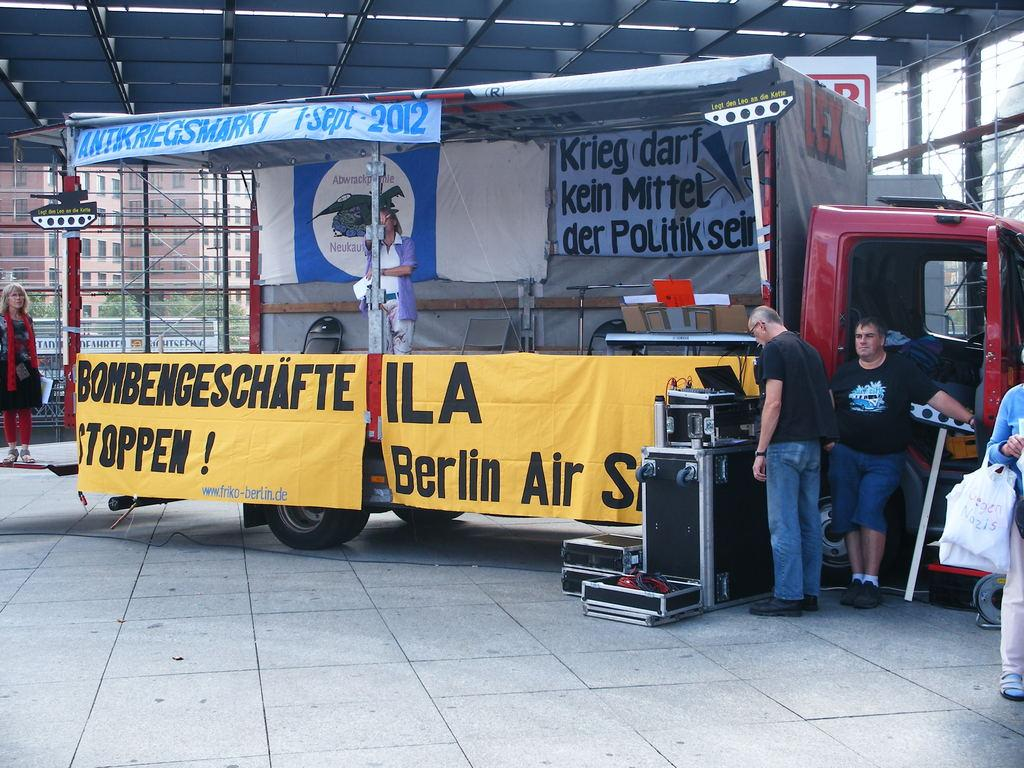What is the main subject of the image? There is a vehicle in the image. Are there any people present in the image? Yes, there are persons in the image. What other objects can be seen in the image? There are banners, chairs, and devices in the image. What can be seen in the background of the image? There are buildings, a board, glasses, and trees in the background of the image. What type of celery is being served to the mother in the image? There is no mother or celery present in the image. What is the selection process for the devices in the image? The image does not show a selection process for the devices; it only shows the devices themselves. 